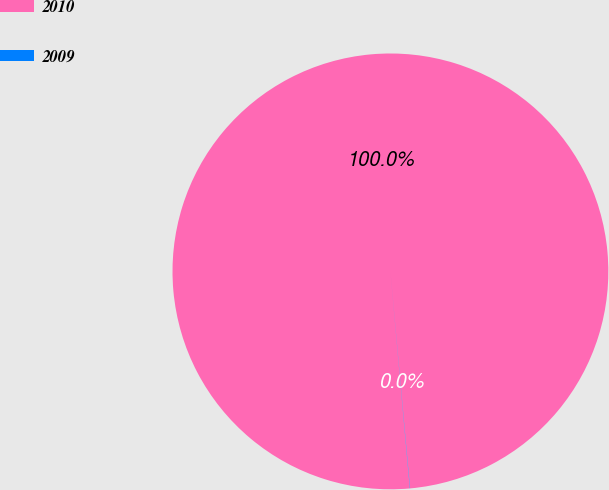<chart> <loc_0><loc_0><loc_500><loc_500><pie_chart><fcel>2010<fcel>2009<nl><fcel>99.98%<fcel>0.02%<nl></chart> 